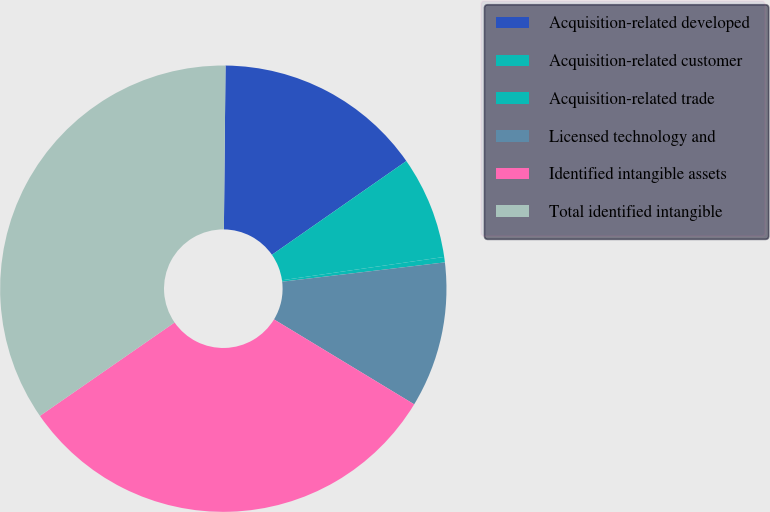<chart> <loc_0><loc_0><loc_500><loc_500><pie_chart><fcel>Acquisition-related developed<fcel>Acquisition-related customer<fcel>Acquisition-related trade<fcel>Licensed technology and<fcel>Identified intangible assets<fcel>Total identified intangible<nl><fcel>15.15%<fcel>7.42%<fcel>0.39%<fcel>10.55%<fcel>31.68%<fcel>34.81%<nl></chart> 